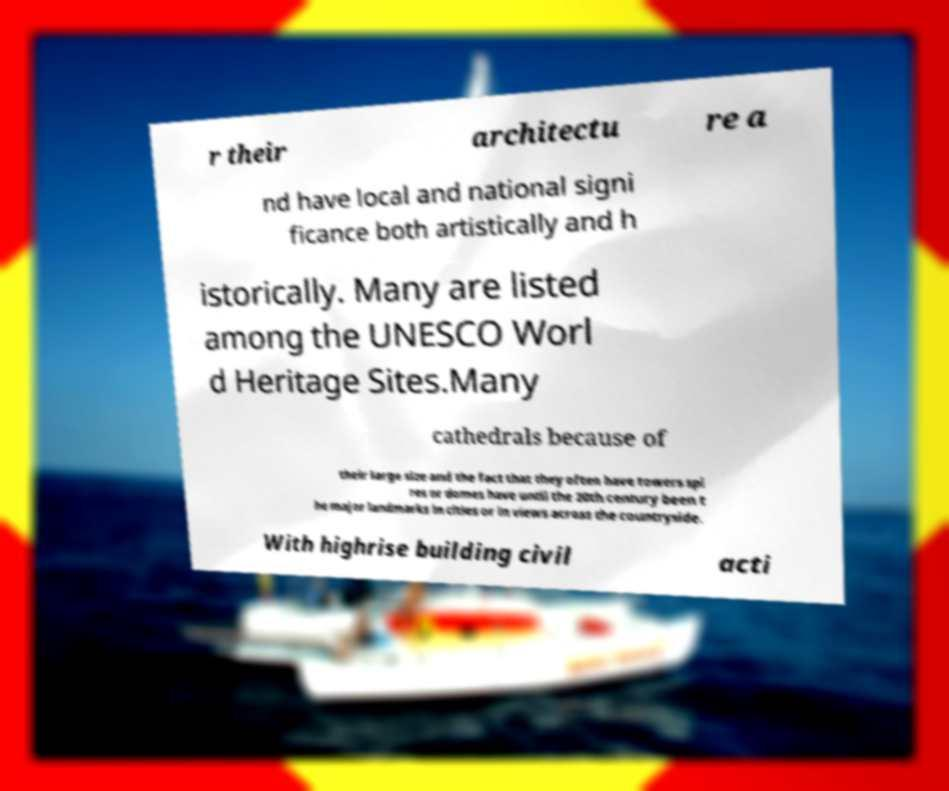What messages or text are displayed in this image? I need them in a readable, typed format. r their architectu re a nd have local and national signi ficance both artistically and h istorically. Many are listed among the UNESCO Worl d Heritage Sites.Many cathedrals because of their large size and the fact that they often have towers spi res or domes have until the 20th century been t he major landmarks in cities or in views across the countryside. With highrise building civil acti 